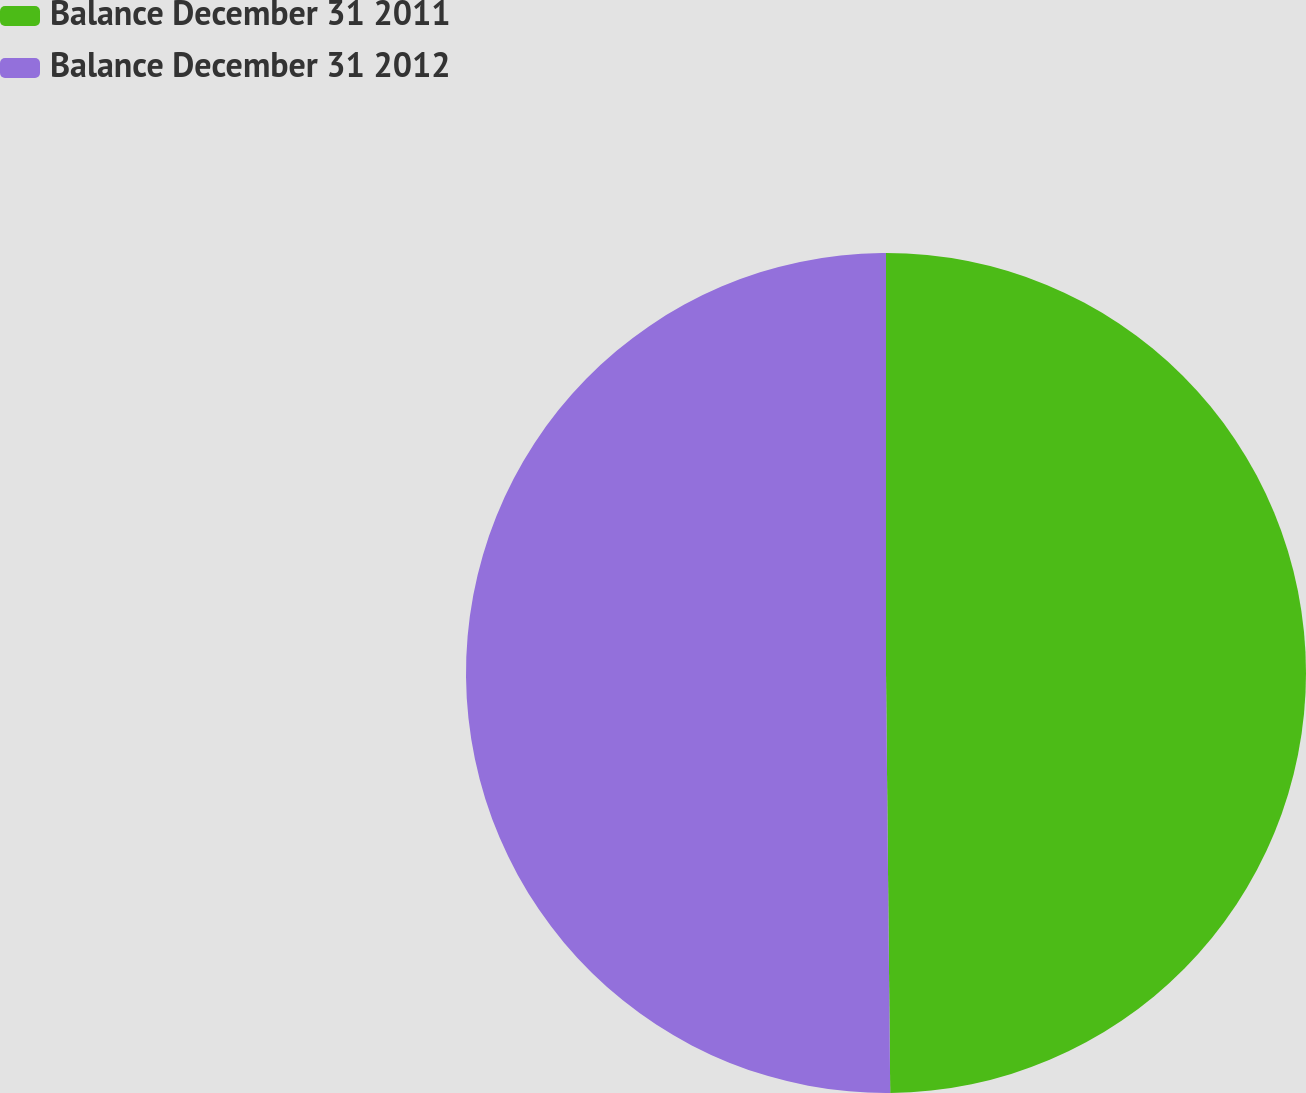<chart> <loc_0><loc_0><loc_500><loc_500><pie_chart><fcel>Balance December 31 2011<fcel>Balance December 31 2012<nl><fcel>49.84%<fcel>50.16%<nl></chart> 